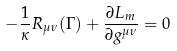Convert formula to latex. <formula><loc_0><loc_0><loc_500><loc_500>- \frac { 1 } { \kappa } R _ { \mu \nu } ( \Gamma ) + \frac { \partial L _ { m } } { \partial g ^ { \mu \nu } } = 0</formula> 